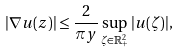<formula> <loc_0><loc_0><loc_500><loc_500>| \nabla u ( z ) | \leq \frac { 2 } { \pi y } \sup _ { \zeta \in { \mathbb { R } } _ { + } ^ { 2 } } | u ( \zeta ) | ,</formula> 